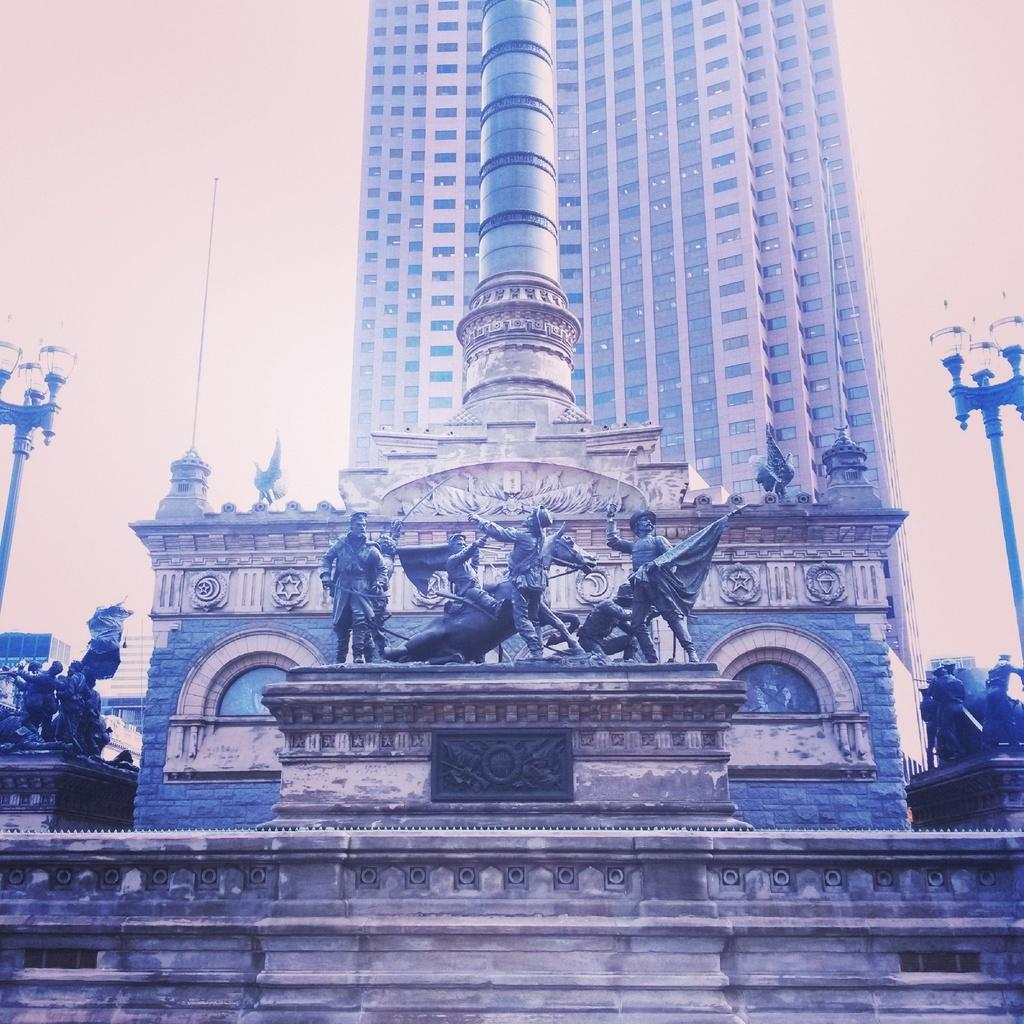What type of art is present in the image? There are sculptures in the image. What other objects can be seen in the image besides the sculptures? There are poles, lights, and buildings visible in the image. What is visible in the background of the image? The sky is visible in the background of the image. What type of jeans is the sculpture wearing in the image? There are no jeans present in the image, as the subjects are sculptures and not people. What type of instrument is being played by the sculpture in the image? There is no instrument present in the image, as the subjects are sculptures and not musicians. 